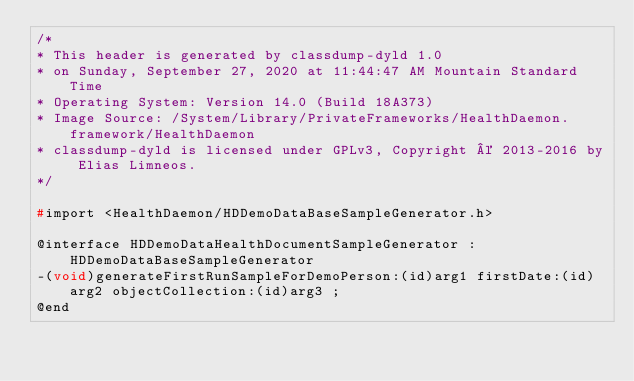<code> <loc_0><loc_0><loc_500><loc_500><_C_>/*
* This header is generated by classdump-dyld 1.0
* on Sunday, September 27, 2020 at 11:44:47 AM Mountain Standard Time
* Operating System: Version 14.0 (Build 18A373)
* Image Source: /System/Library/PrivateFrameworks/HealthDaemon.framework/HealthDaemon
* classdump-dyld is licensed under GPLv3, Copyright © 2013-2016 by Elias Limneos.
*/

#import <HealthDaemon/HDDemoDataBaseSampleGenerator.h>

@interface HDDemoDataHealthDocumentSampleGenerator : HDDemoDataBaseSampleGenerator
-(void)generateFirstRunSampleForDemoPerson:(id)arg1 firstDate:(id)arg2 objectCollection:(id)arg3 ;
@end

</code> 